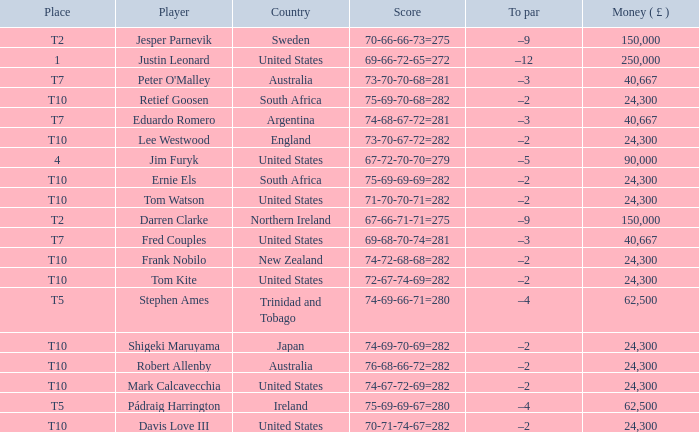How much money has been won by Stephen Ames? 62500.0. 